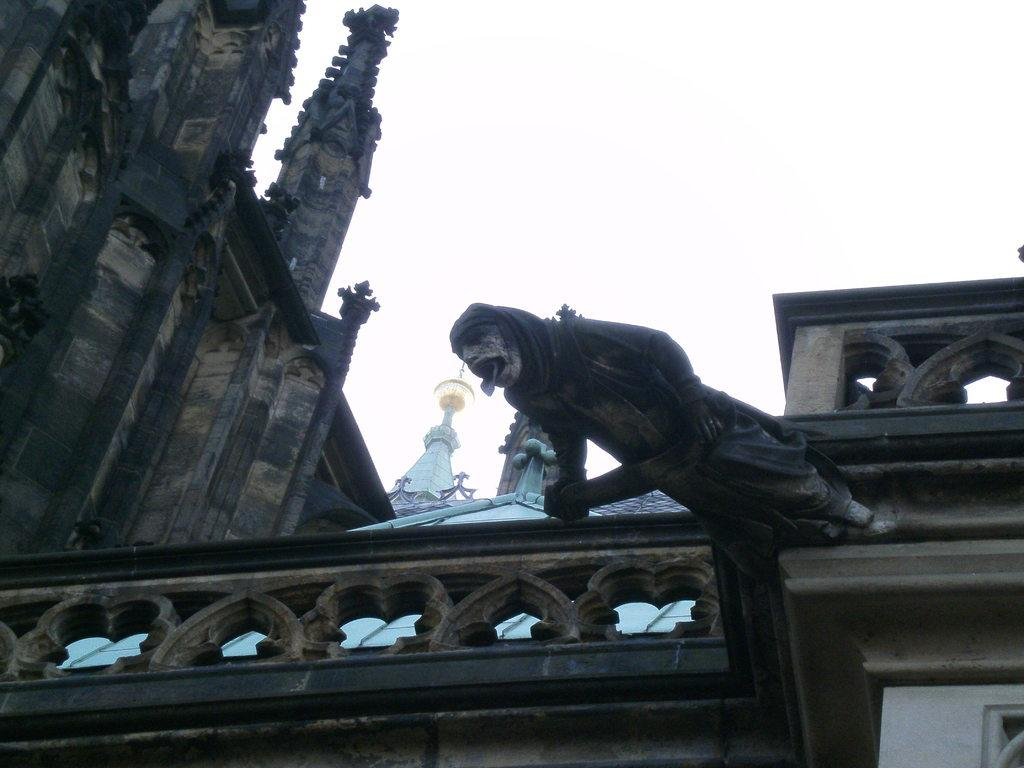What type of structure is visible in the image? There is architecture in the picture. Can you describe any additional features of the architecture? Yes, there is a sculpture attached to the architecture on the right side. How many dogs are visible in the image? There are no dogs present in the image. What type of fuel is being used by the sculpture in the image? The image does not show any fuel being used by the sculpture, as it is a static object attached to the architecture. 